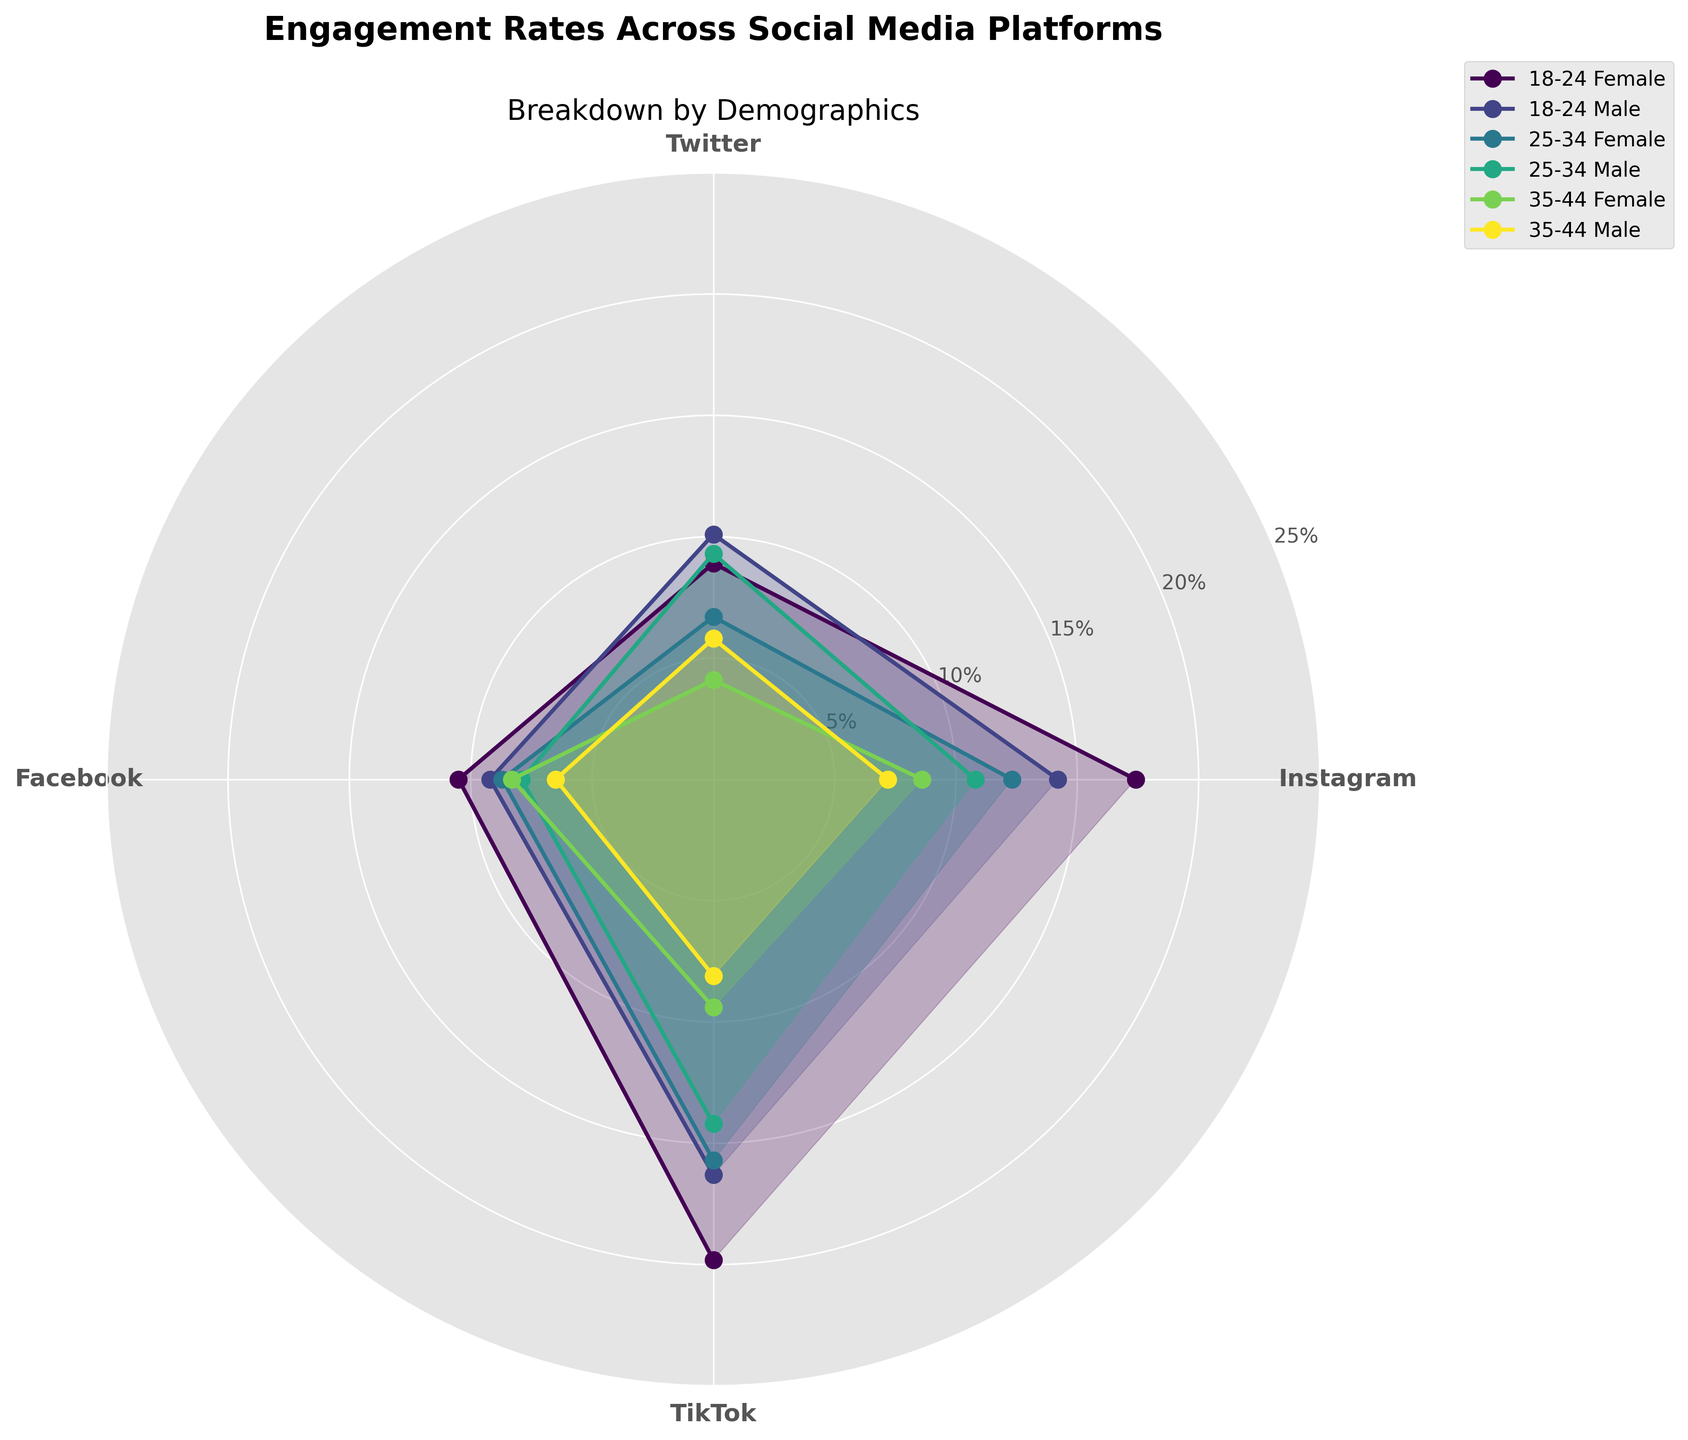What's the title of the figure? The title is located at the top and clearly states the subject of the chart. It reads "Engagement Rates Across Social Media Platforms".
Answer: Engagement Rates Across Social Media Platforms Which demographic group has the highest engagement rate on Instagram? By examining the plots for Instagram, we see that the peak is at 17.4% for the "18-24 Female" demographic. We identify this highest point by comparing all demographic segments for Instagram.
Answer: 18-24 Female What is the difference between the highest engagement rates on Instagram and TikTok for the "18-24 Male" demographic? From the chart, the "18-24 Male" demographic has an engagement rate of 14.2% on Instagram and 16.3% on TikTok. The difference is calculated as 16.3% - 14.2%.
Answer: 2.1% Which platform has the lowest engagement rate for the "35-44 Female" demographic? By comparing the engagement rates for the "35-44 Female" demographic across all platforms, we see the lowest value is for Twitter at 4.1%.
Answer: Twitter Are engagement rates generally higher for females or males across platforms? Comparing the engagement rates across all demographic groups for each platform, it is visible that females generally have higher engagement rates than males in most cases (e.g., Instagram, TikTok) with a few exceptions (e.g., Twitter).
Answer: Females Determine the average engagement rate for males in the "25-34" age group across all platforms. Collect and sum the engagement rates for males aged 25-34 from all platforms (10.8% from Instagram, 9.3% from Twitter, 7.9% from Facebook, and 14.2% from TikTok); then divide by 4: (10.8 + 9.3 + 7.9 + 14.2) / 4.
Answer: 10.55% How do the engagement rates for "25-34 Female" on Facebook and Twitter compare? From the figure, "25-34 Female" engagement rates are 8.7% on Facebook and 6.7% on Twitter. Facebook has a higher rate by 2%.
Answer: Facebook has a higher rate What is the total engagement rate for the "35-44 Male" demographic across Instagram, Twitter, Facebook, and TikTok? Sum the engagement rates for "35-44 Male" across all platforms (7.2% from Instagram, 5.8% from Twitter, 6.5% from Facebook, and 8.1% from TikTok): 7.2 + 5.8 + 6.5 + 8.1.
Answer: 27.6% Which demographic has the largest variance in engagement rates across platforms? Examining each demographic, the "18-24 Female" group shows large variations with high rates on TikTok and Instagram and much lower rates on Twitter and Facebook.
Answer: 18-24 Female Which social media platform is the most engaging for the "25-34 Male" demographic? By comparing the engagement rates of "25-34 Male" across all platforms, TikTok has the highest rate at 14.2%.
Answer: TikTok 